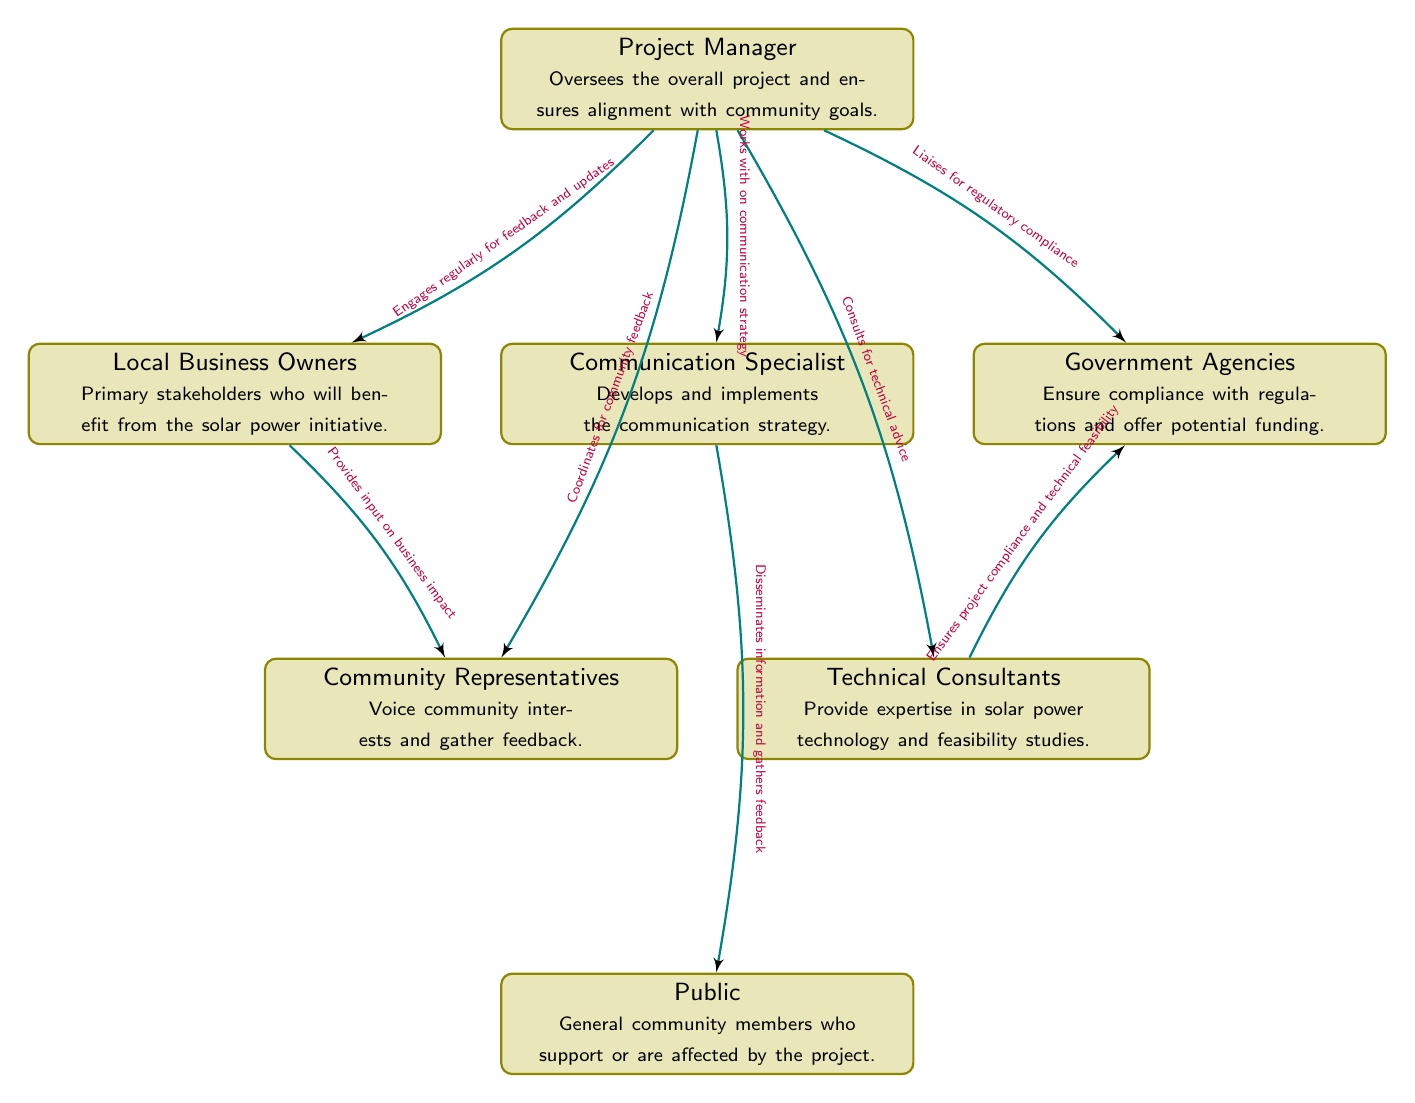What is the role of the Project Manager? The Project Manager's role is explicitly defined in the diagram, stating that they oversee the overall project and ensure alignment with community goals.
Answer: Oversees the overall project and ensures alignment with community goals How many stakeholders are depicted in the diagram? By counting the distinct rectangles labeled with stakeholder titles in the diagram, we find there are a total of seven stakeholders.
Answer: 7 Who provides input on business impact? The diagram indicates that Local Business Owners provide input on business impact by connecting them to Community Representatives with the labeled relationship.
Answer: Local Business Owners What is the primary interaction between the Project Manager and the Communication Specialist? According to the diagram, the Project Manager works with the Communication Specialist on the communication strategy, highlighting their collaborative interaction.
Answer: Works with on communication strategy What does the Technical Consultant ensure in relation to Government Agencies? The diagram presents a relationship where Technical Consultants ensure project compliance and technical feasibility, indicating their role in providing critical feedback to Government Agencies.
Answer: Ensures project compliance and technical feasibility How frequently does the Project Manager engage with Local Business Owners? The diagram shows a consistent flow of interaction where the Project Manager engages regularly for feedback and updates, indicating ongoing communication.
Answer: Regularly for feedback and updates What type of feedback does the Communication Specialist gather from the Public? The diagram notes that the Communication Specialist disseminates information and gathers feedback from the Public, suggesting they collect opinions and reactions from general community members.
Answer: Feedback Which stakeholder liaises for regulatory compliance? The diagram highlights that the Project Manager is responsible for liaising with Government Agencies to ensure regulatory compliance, signifying a direct responsibility connection.
Answer: Project Manager 